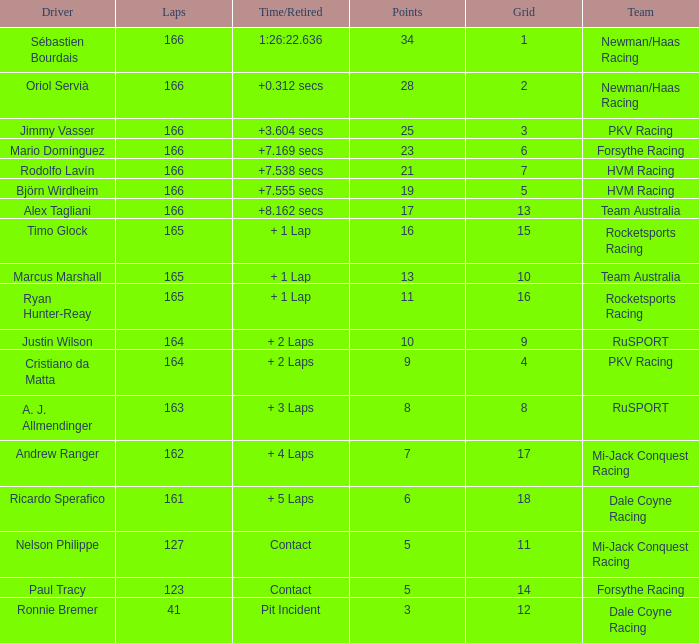What is the name of the driver with 6 points? Ricardo Sperafico. 